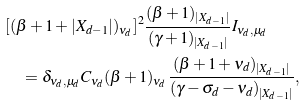Convert formula to latex. <formula><loc_0><loc_0><loc_500><loc_500>& [ ( \beta + 1 + | X _ { d - 1 } | ) _ { \nu _ { d } } ] ^ { 2 } \frac { ( \beta + 1 ) _ { | X _ { d - 1 } | } } { ( \gamma + 1 ) _ { | X _ { d - 1 } | } } I _ { \nu _ { d } , \mu _ { d } } \\ & \quad = \delta _ { \nu _ { d } , \mu _ { d } } C _ { \nu _ { d } } ( \beta + 1 ) _ { \nu _ { d } } \frac { ( \beta + 1 + \nu _ { d } ) _ { | X _ { d - 1 } | } } { ( \gamma - \sigma _ { d } - \nu _ { d } ) _ { | X _ { d - 1 } | } } ,</formula> 